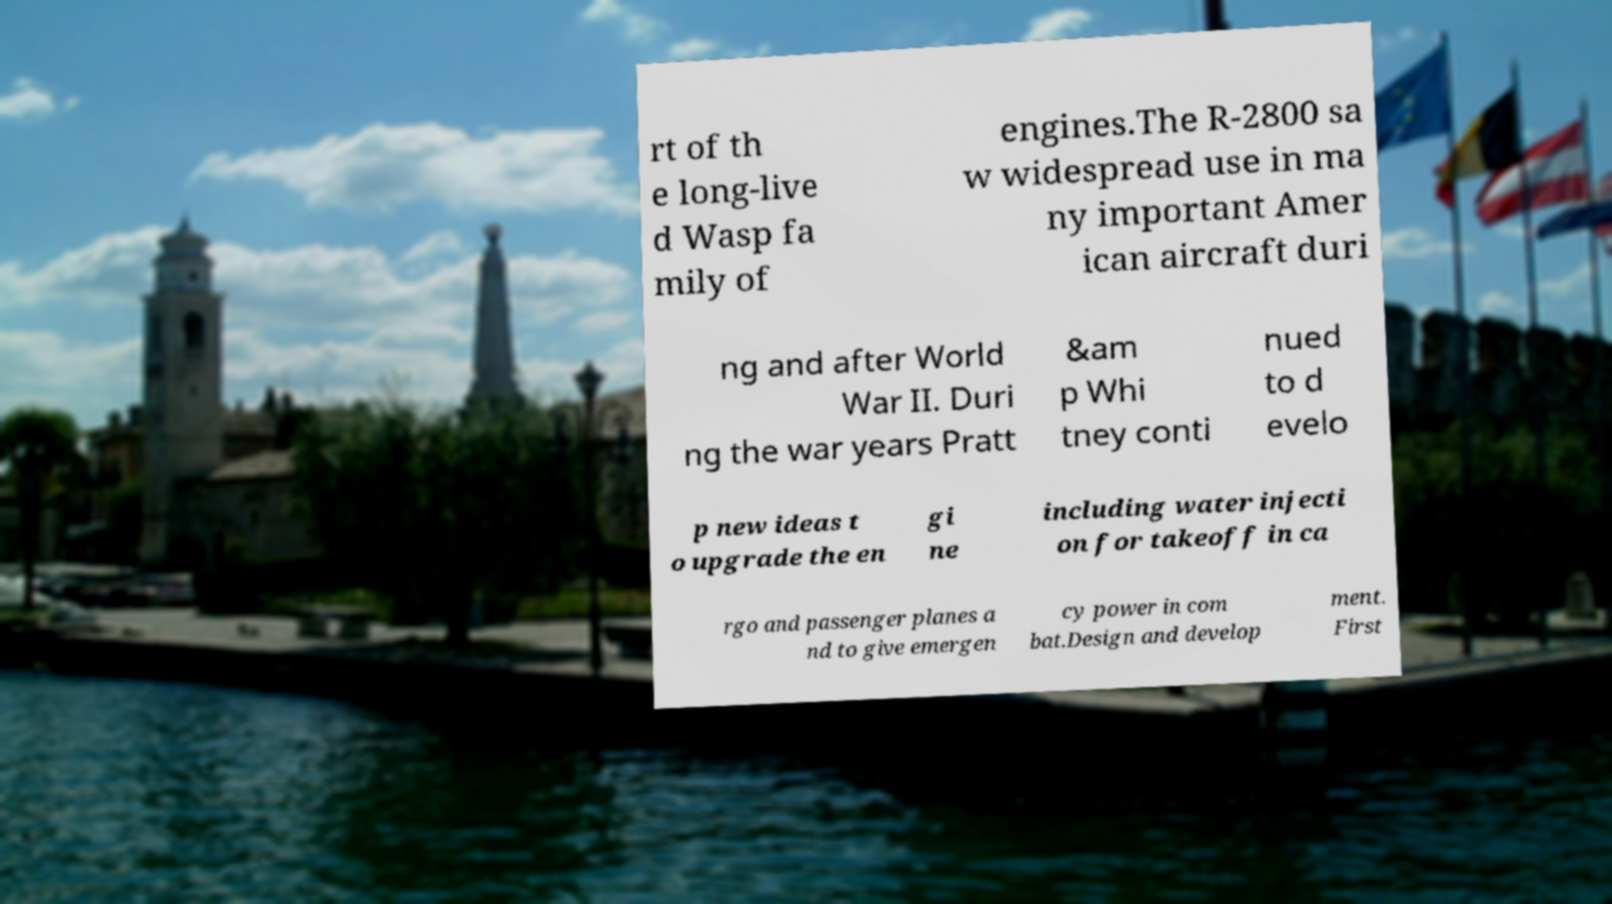Can you read and provide the text displayed in the image?This photo seems to have some interesting text. Can you extract and type it out for me? rt of th e long-live d Wasp fa mily of engines.The R-2800 sa w widespread use in ma ny important Amer ican aircraft duri ng and after World War II. Duri ng the war years Pratt &am p Whi tney conti nued to d evelo p new ideas t o upgrade the en gi ne including water injecti on for takeoff in ca rgo and passenger planes a nd to give emergen cy power in com bat.Design and develop ment. First 